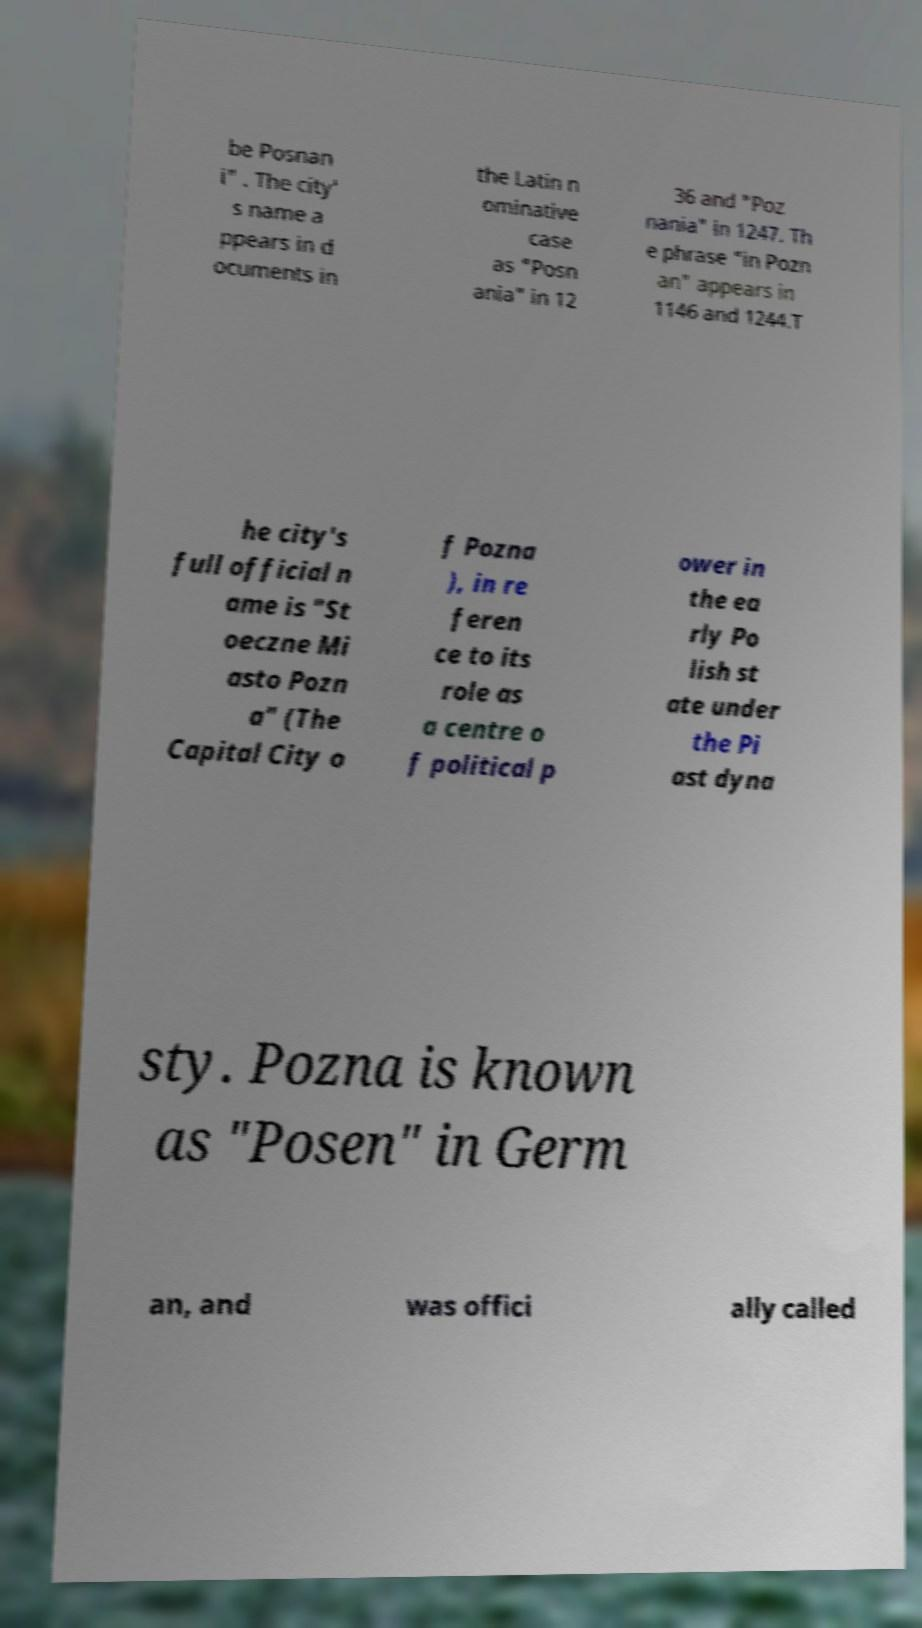For documentation purposes, I need the text within this image transcribed. Could you provide that? be Posnan i" . The city' s name a ppears in d ocuments in the Latin n ominative case as "Posn ania" in 12 36 and "Poz nania" in 1247. Th e phrase "in Pozn an" appears in 1146 and 1244.T he city's full official n ame is "St oeczne Mi asto Pozn a" (The Capital City o f Pozna ), in re feren ce to its role as a centre o f political p ower in the ea rly Po lish st ate under the Pi ast dyna sty. Pozna is known as "Posen" in Germ an, and was offici ally called 